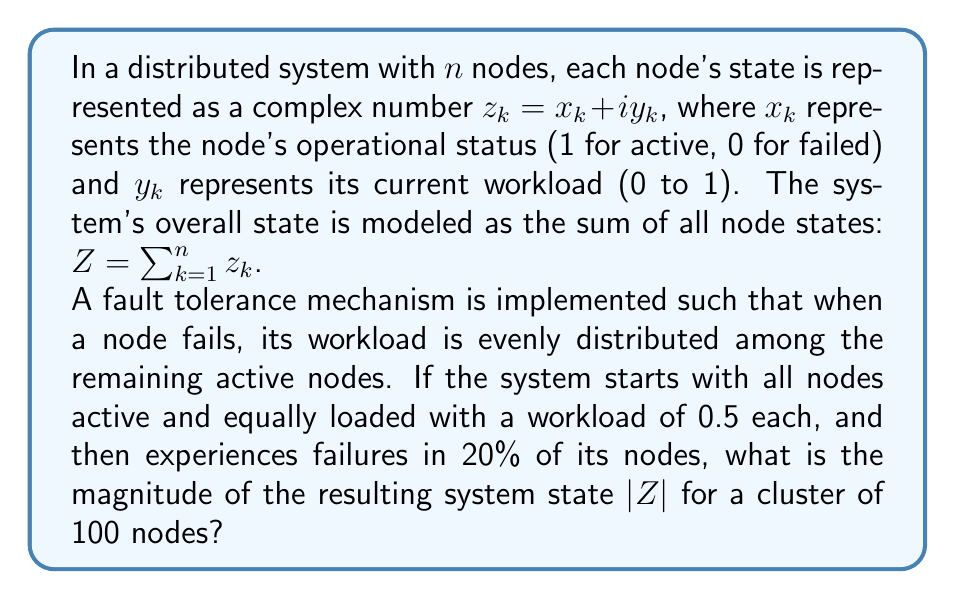Could you help me with this problem? Let's approach this step-by-step:

1) Initially, all nodes are active and equally loaded:
   $z_k = 1 + 0.5i$ for all $k$
   
2) The initial system state is:
   $Z_{initial} = \sum_{k=1}^{100} (1 + 0.5i) = 100 + 50i$

3) After 20% of nodes fail:
   - Number of failed nodes: $100 * 0.2 = 20$
   - Number of active nodes: $100 - 20 = 80$

4) The workload of failed nodes is redistributed:
   - Total workload to redistribute: $20 * 0.5 = 10$
   - Additional workload per active node: $10 / 80 = 0.125$

5) New state of each active node:
   $z_{active} = 1 + (0.5 + 0.125)i = 1 + 0.625i$

6) The new system state is:
   $Z_{new} = 80 * (1 + 0.625i) = 80 + 50i$

7) The magnitude of the new system state is:
   $|Z_{new}| = \sqrt{80^2 + 50^2} = \sqrt{6400 + 2500} = \sqrt{8900} \approx 94.34$
Answer: The magnitude of the resulting system state $|Z|$ for a cluster of 100 nodes after 20% node failures is approximately 94.34. 